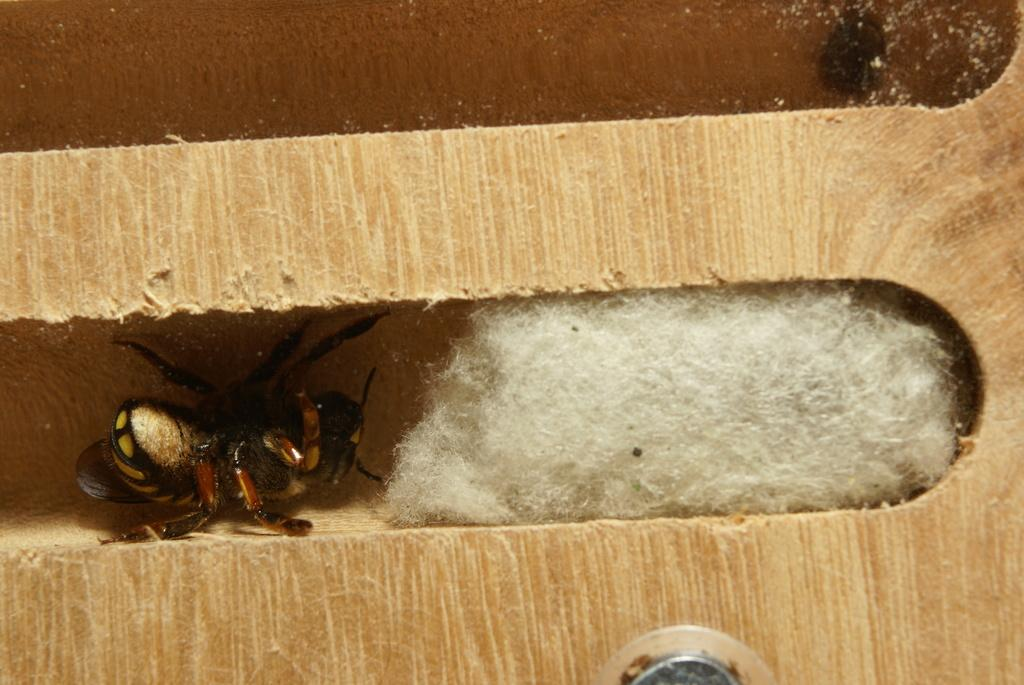What type of creature can be seen in the image? There is an insect in the image. What material is present in the image? There is cotton in the image. What type of object is made of wood in the image? There is a wooden plank in the image. What is attached to the bottom of the wooden plank in the image? There is a screw-like structure at the bottom of the plank in the image. What type of frog is sitting on the wooden plank in the image? There is no frog present in the image; it features an insect, cotton, a wooden plank, and a screw-like structure. What color are the trousers worn by the insect in the image? There are no trousers present in the image, as insects do not wear clothing. 